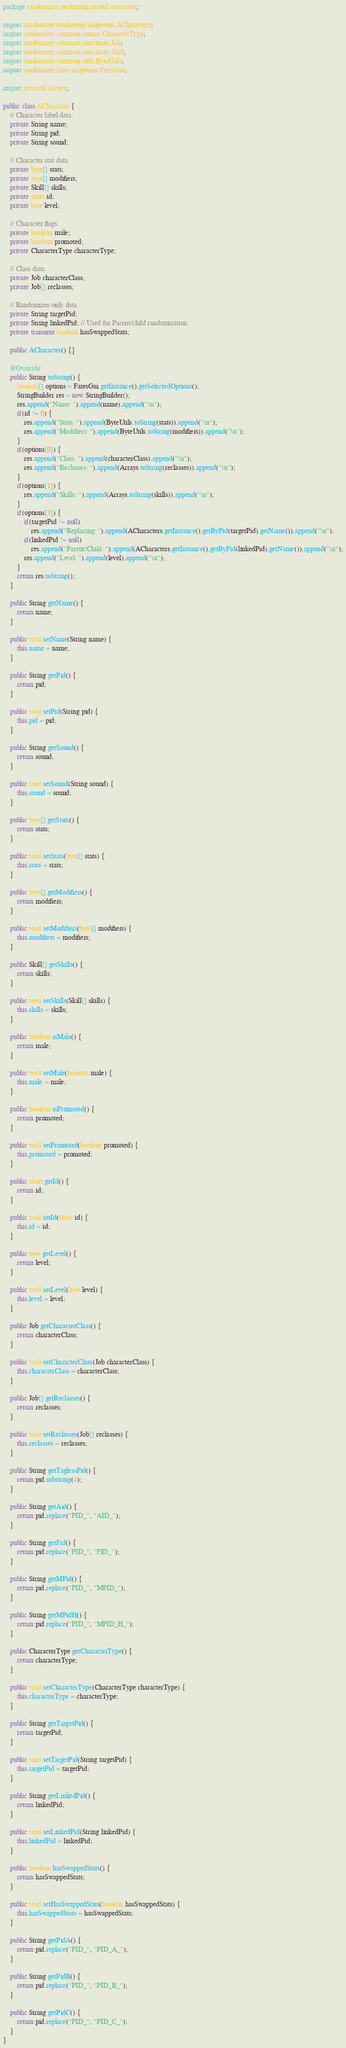<code> <loc_0><loc_0><loc_500><loc_500><_Java_>package randomizer.awakening.model.structures;

import randomizer.awakening.singletons.ACharacters;
import randomizer.common.enums.CharacterType;
import randomizer.common.structures.Job;
import randomizer.common.structures.Skill;
import randomizer.common.utils.ByteUtils;
import randomizer.fates.singletons.FatesGui;

import java.util.Arrays;

public class ACharacter {
    // Character label data.
    private String name;
    private String pid;
    private String sound;

    // Character stat data.
    private byte[] stats;
    private byte[] modifiers;
    private Skill[] skills;
    private short id;
    private byte level;

    // Character flags.
    private boolean male;
    private boolean promoted;
    private CharacterType characterType;

    // Class data.
    private Job characterClass;
    private Job[] reclasses;

    // Randomizer-only data.
    private String targetPid;
    private String linkedPid; // Used for Parent/child randomization.
    private transient boolean hasSwappedStats;

    public ACharacter() {}

    @Override
    public String toString() {
        boolean[] options = FatesGui.getInstance().getSelectedOptions();
        StringBuilder res = new StringBuilder();
        res.append("Name: ").append(name).append("\n");
        if(id != 0) {
            res.append("Stats: ").append(ByteUtils.toString(stats)).append("\n");
            res.append("Modifiers: ").append(ByteUtils.toString(modifiers)).append("\n");
        }
        if(options[0]) {
            res.append("Class: ").append(characterClass).append("\n");
            res.append("Reclasses: ").append(Arrays.toString(reclasses)).append("\n");
        }
        if(options[1]) {
            res.append("Skills: ").append(Arrays.toString(skills)).append("\n");
        }
        if(options[3]) {
            if(targetPid != null)
                res.append("Replacing: ").append(ACharacters.getInstance().getByPid(targetPid).getName()).append("\n");
            if(linkedPid != null)
                res.append("Parent/Child: ").append(ACharacters.getInstance().getByPid(linkedPid).getName()).append("\n");
            res.append("Level: ").append(level).append("\n");
        }
        return res.toString();
    }

    public String getName() {
        return name;
    }

    public void setName(String name) {
        this.name = name;
    }

    public String getPid() {
        return pid;
    }

    public void setPid(String pid) {
        this.pid = pid;
    }

    public String getSound() {
        return sound;
    }

    public void setSound(String sound) {
        this.sound = sound;
    }

    public byte[] getStats() {
        return stats;
    }

    public void setStats(byte[] stats) {
        this.stats = stats;
    }

    public byte[] getModifiers() {
        return modifiers;
    }

    public void setModifiers(byte[] modifiers) {
        this.modifiers = modifiers;
    }

    public Skill[] getSkills() {
        return skills;
    }

    public void setSkills(Skill[] skills) {
        this.skills = skills;
    }

    public boolean isMale() {
        return male;
    }

    public void setMale(boolean male) {
        this.male = male;
    }

    public boolean isPromoted() {
        return promoted;
    }

    public void setPromoted(boolean promoted) {
        this.promoted = promoted;
    }

    public short getId() {
        return id;
    }

    public void setId(short id) {
        this.id = id;
    }

    public byte getLevel() {
        return level;
    }

    public void setLevel(byte level) {
        this.level = level;
    }

    public Job getCharacterClass() {
        return characterClass;
    }

    public void setCharacterClass(Job characterClass) {
        this.characterClass = characterClass;
    }

    public Job[] getReclasses() {
        return reclasses;
    }

    public void setReclasses(Job[] reclasses) {
        this.reclasses = reclasses;
    }

    public String getTaglessPid() {
        return pid.substring(4);
    }

    public String getAid() {
        return pid.replace("PID_", "AID_");
    }

    public String getFid() {
        return pid.replace("PID_", "FID_");
    }

    public String getMPid() {
        return pid.replace("PID_", "MPID_");
    }

    public String getMPidH() {
        return pid.replace("PID_", "MPID_H_");
    }

    public CharacterType getCharacterType() {
        return characterType;
    }

    public void setCharacterType(CharacterType characterType) {
        this.characterType = characterType;
    }

    public String getTargetPid() {
        return targetPid;
    }

    public void setTargetPid(String targetPid) {
        this.targetPid = targetPid;
    }

    public String getLinkedPid() {
        return linkedPid;
    }

    public void setLinkedPid(String linkedPid) {
        this.linkedPid = linkedPid;
    }

    public boolean hasSwappedStats() {
        return hasSwappedStats;
    }

    public void setHasSwappedStats(boolean hasSwappedStats) {
        this.hasSwappedStats = hasSwappedStats;
    }

    public String getPidA() {
        return pid.replace("PID_", "PID_A_");
    }

    public String getPidB() {
        return pid.replace("PID_", "PID_B_");
    }

    public String getPidC() {
        return pid.replace("PID_", "PID_C_");
    }
}
</code> 